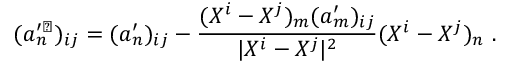Convert formula to latex. <formula><loc_0><loc_0><loc_500><loc_500>( a _ { n } ^ { \prime \perp } ) _ { i j } = ( a _ { n } ^ { \prime } ) _ { i j } - \frac { ( X ^ { i } - X ^ { j } ) _ { m } ( a _ { m } ^ { \prime } ) _ { i j } } { | X ^ { i } - X ^ { j } | ^ { 2 } } ( X ^ { i } - X ^ { j } ) _ { n } \ .</formula> 